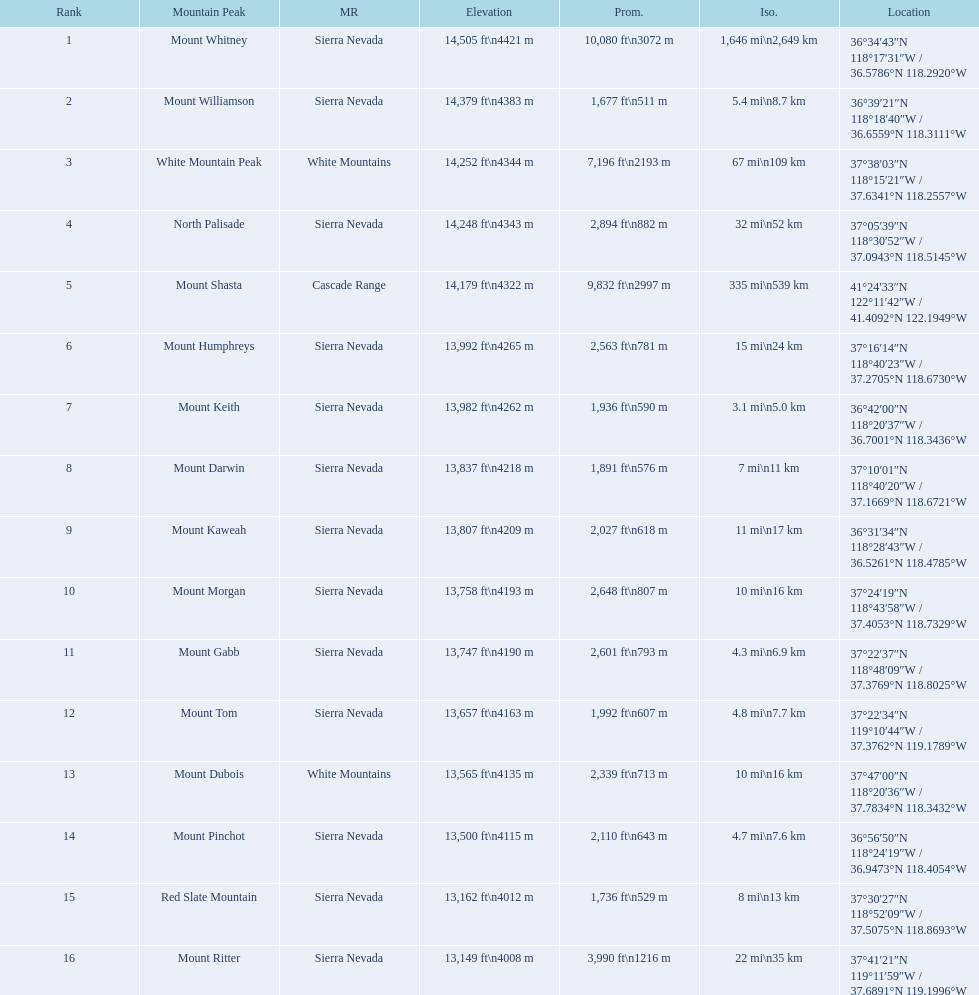Which mountain peak is in the white mountains range? White Mountain Peak. Which mountain is in the sierra nevada range? Mount Whitney. Which mountain is the only one in the cascade range? Mount Shasta. 